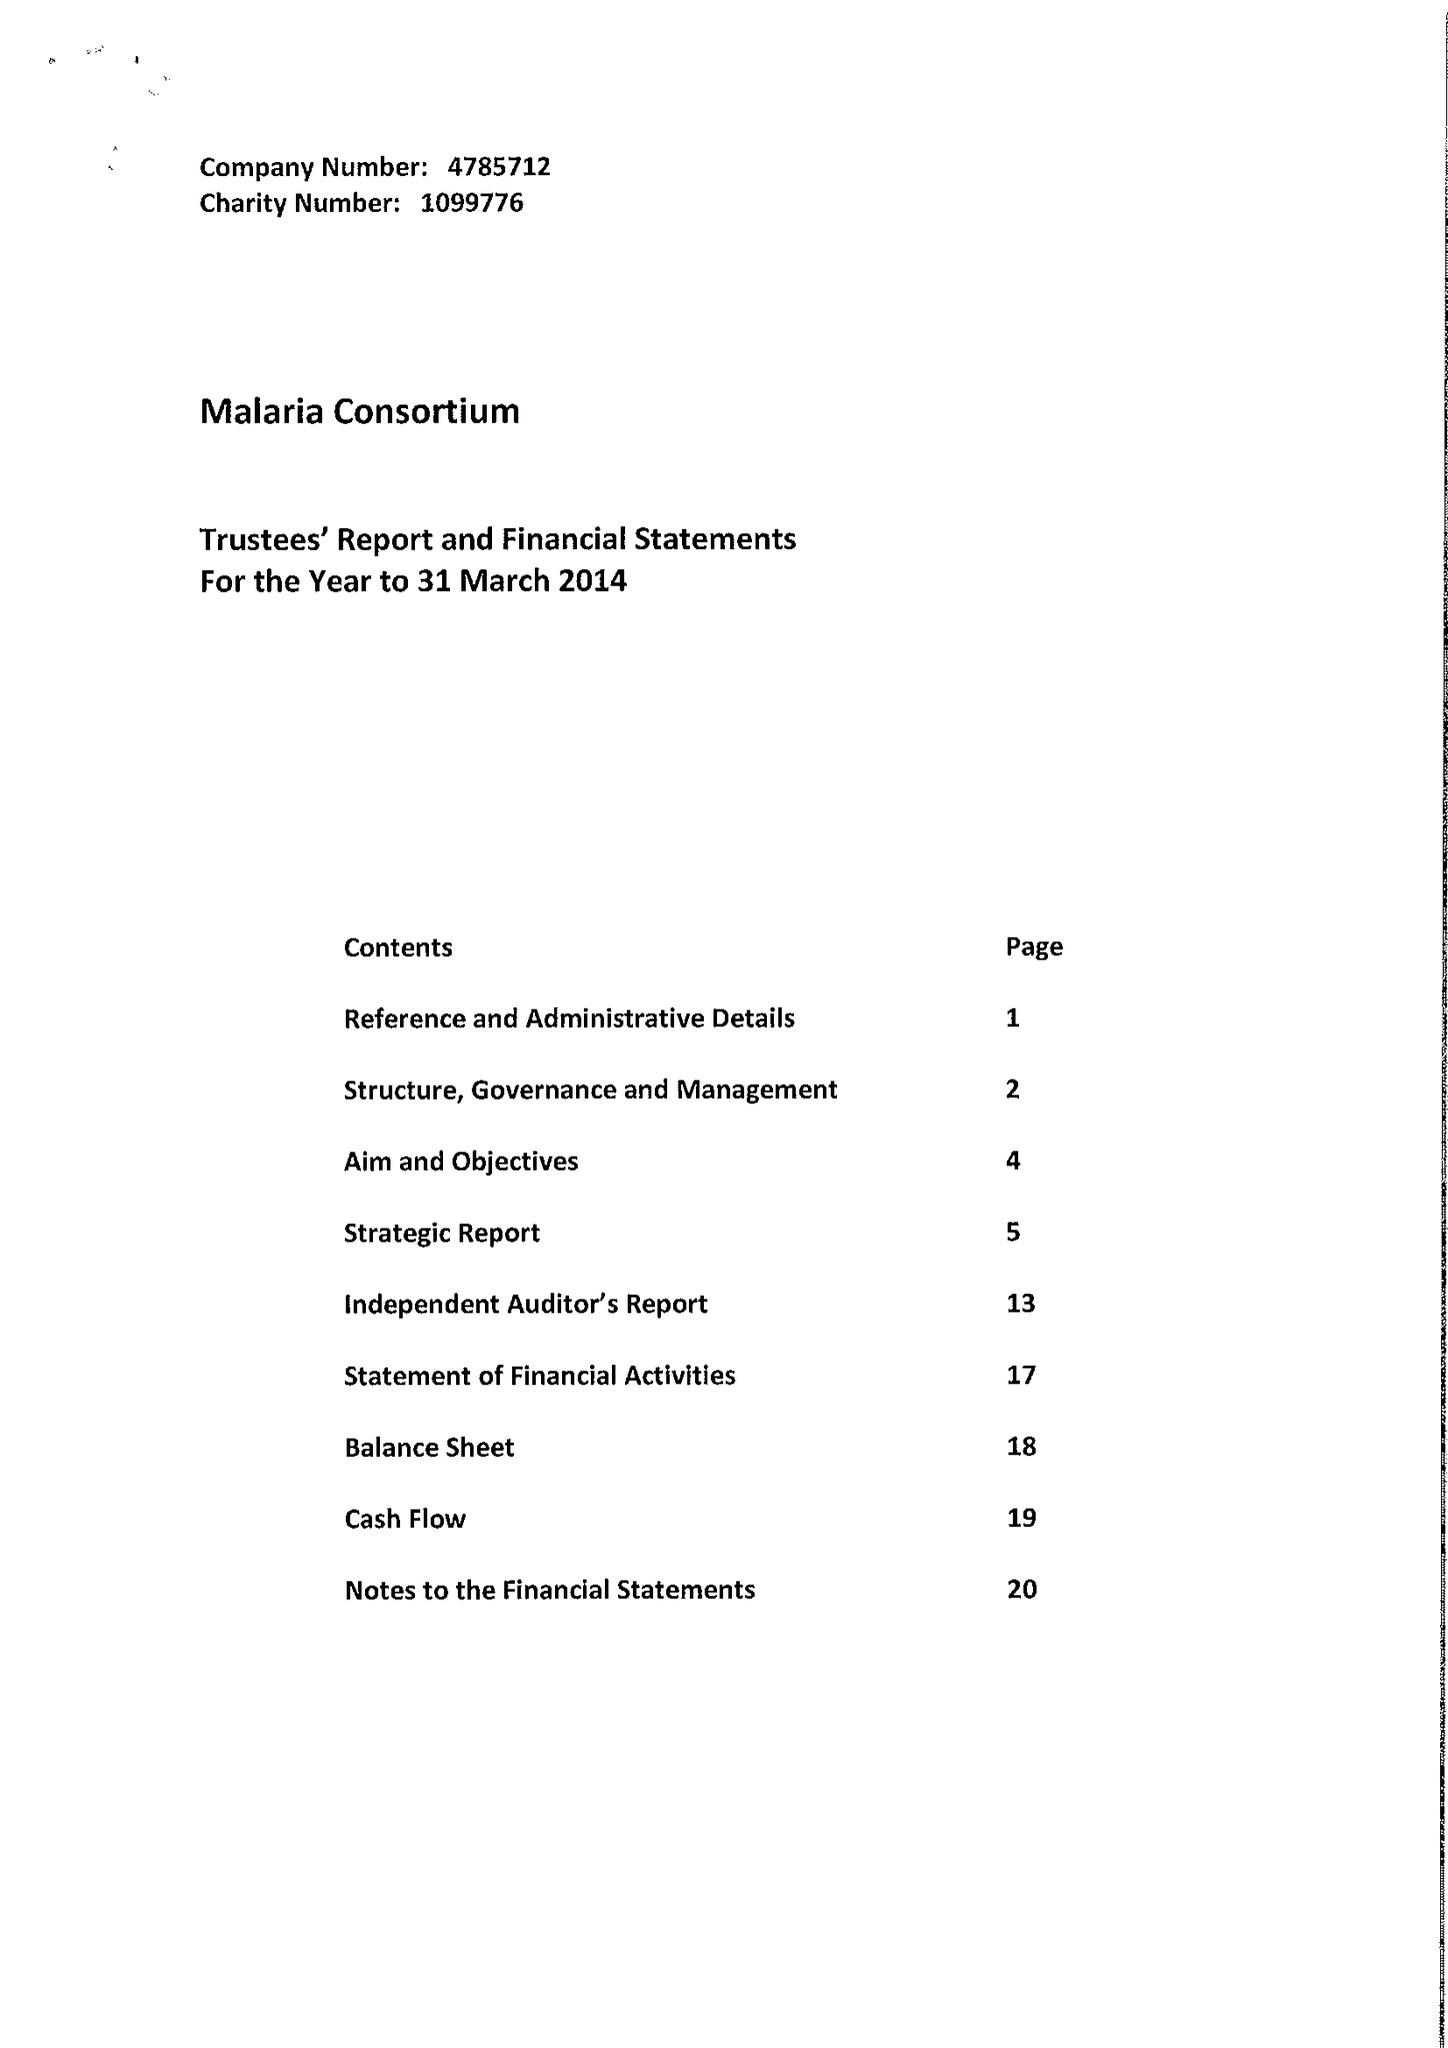What is the value for the address__post_town?
Answer the question using a single word or phrase. LONDON 